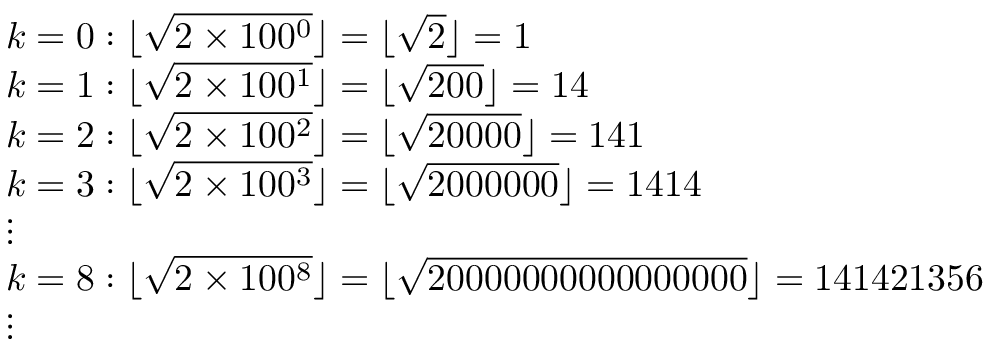Convert formula to latex. <formula><loc_0><loc_0><loc_500><loc_500>{ \begin{array} { r l } & { k = 0 \colon \lfloor { \sqrt { 2 \times 1 0 0 ^ { 0 } } } \rfloor = \lfloor { \sqrt { 2 } } \rfloor = 1 } \\ & { k = 1 \colon \lfloor { \sqrt { 2 \times 1 0 0 ^ { 1 } } } \rfloor = \lfloor { \sqrt { 2 0 0 } } \rfloor = 1 4 } \\ & { k = 2 \colon \lfloor { \sqrt { 2 \times 1 0 0 ^ { 2 } } } \rfloor = \lfloor { \sqrt { 2 0 0 0 0 } } \rfloor = 1 4 1 } \\ & { k = 3 \colon \lfloor { \sqrt { 2 \times 1 0 0 ^ { 3 } } } \rfloor = \lfloor { \sqrt { 2 0 0 0 0 0 0 } } \rfloor = 1 4 1 4 } \\ & { \vdots } \\ & { k = 8 \colon \lfloor { \sqrt { 2 \times 1 0 0 ^ { 8 } } } \rfloor = \lfloor { \sqrt { 2 0 0 0 0 0 0 0 0 0 0 0 0 0 0 0 0 } } \rfloor = 1 4 1 4 2 1 3 5 6 } \\ & { \vdots } \end{array} }</formula> 